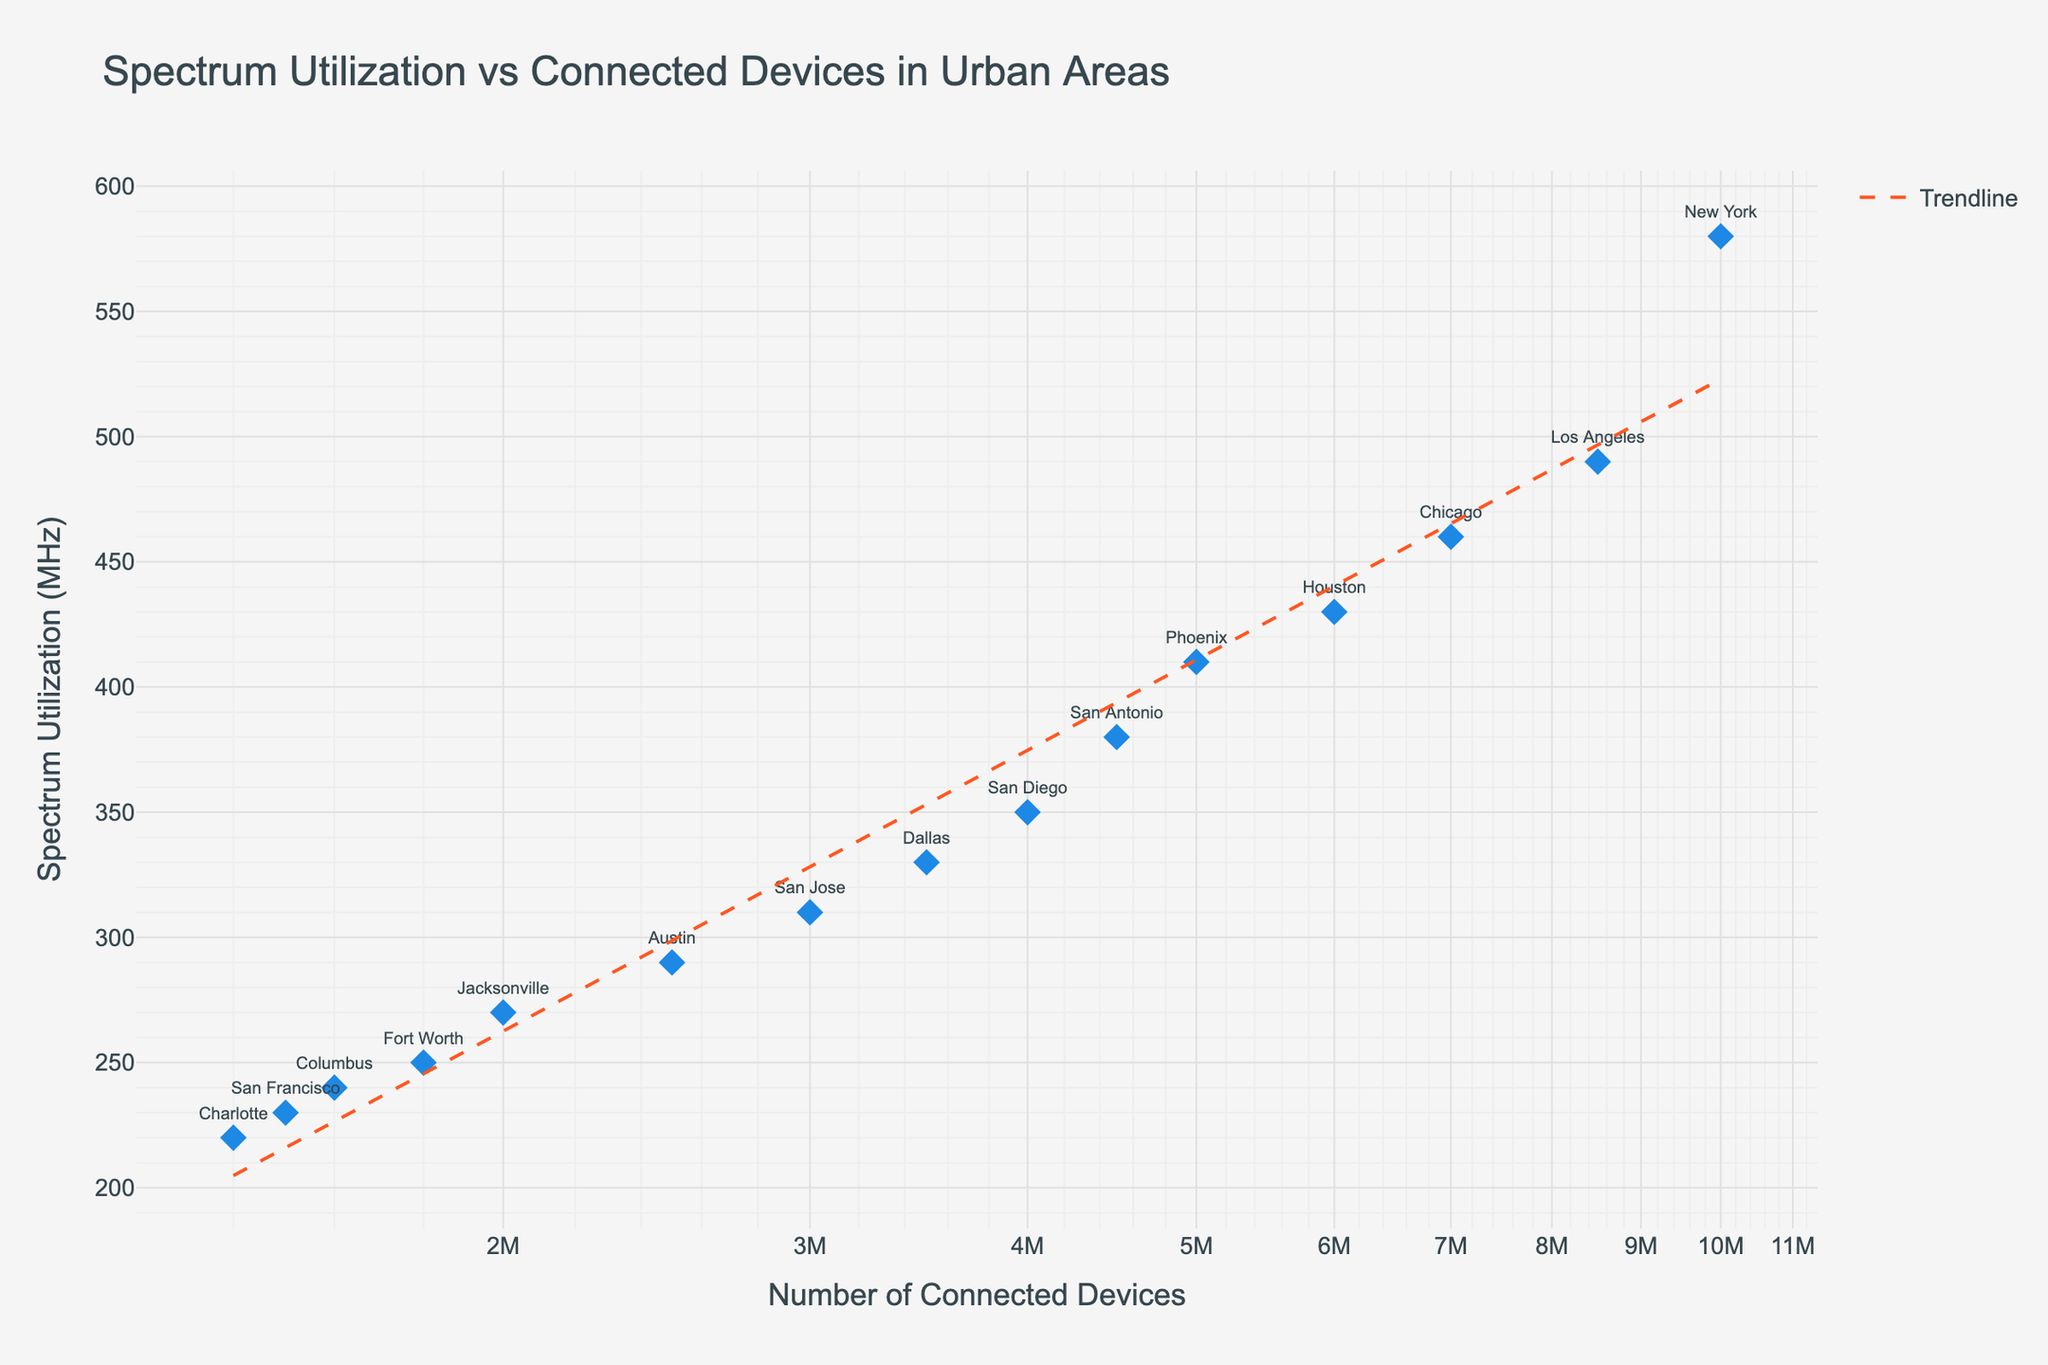What is the title of the scatter plot? The title of the scatter plot is typically found at the top of the figure, indicating the main subject of the plot.
Answer: Spectrum Utilization vs Connected Devices in Urban Areas How many data points are displayed in the scatter plot? Each city represents a data point on the scatter plot. Count the number of unique cities listed.
Answer: 15 Which city has the highest spectrum utilization? The city with the highest spectrum utilization is the one corresponding to the highest y-value on the plot.
Answer: New York Which city has the lowest number of connected devices? The city with the lowest number of connected devices is the one corresponding to the lowest x-value on the plot.
Answer: Charlotte What is the range of spectrum utilization values in the plot? Identify the maximum and minimum y-values representing spectrum utilization in MHz.
Answer: 220 MHz to 580 MHz What is the median number of connected devices among the cities? To find the median number of connected devices, list all connected device values in ascending order and identify the middle value.
Answer: 3,500,000 Compare spectrum utilization between New York and Los Angeles. Which city has higher utilization? Compare the y-values of New York and Los Angeles to determine which is higher.
Answer: New York Is there a trend between the number of connected devices and spectrum utilization? Look at the trendline and its general slope to determine if a positive or negative correlation exists between number of connected devices and spectrum utilization.
Answer: Positive correlation What's the average spectrum utilization for cities with more than 4 million connected devices? Identify cities with more than 4 million connected devices, sum their spectrum utilizations, and divide by the number of such cities.
Answer: (580 + 490 + 460 + 430 + 410) / 5 = 474 MHz Which city has a smaller number of connected devices but higher spectrum utilization than Dallas? Compare the x-values (connected devices) and y-values (spectrum utilization) of Dallas with other cities to find the appropriate match.
Answer: San Diego 